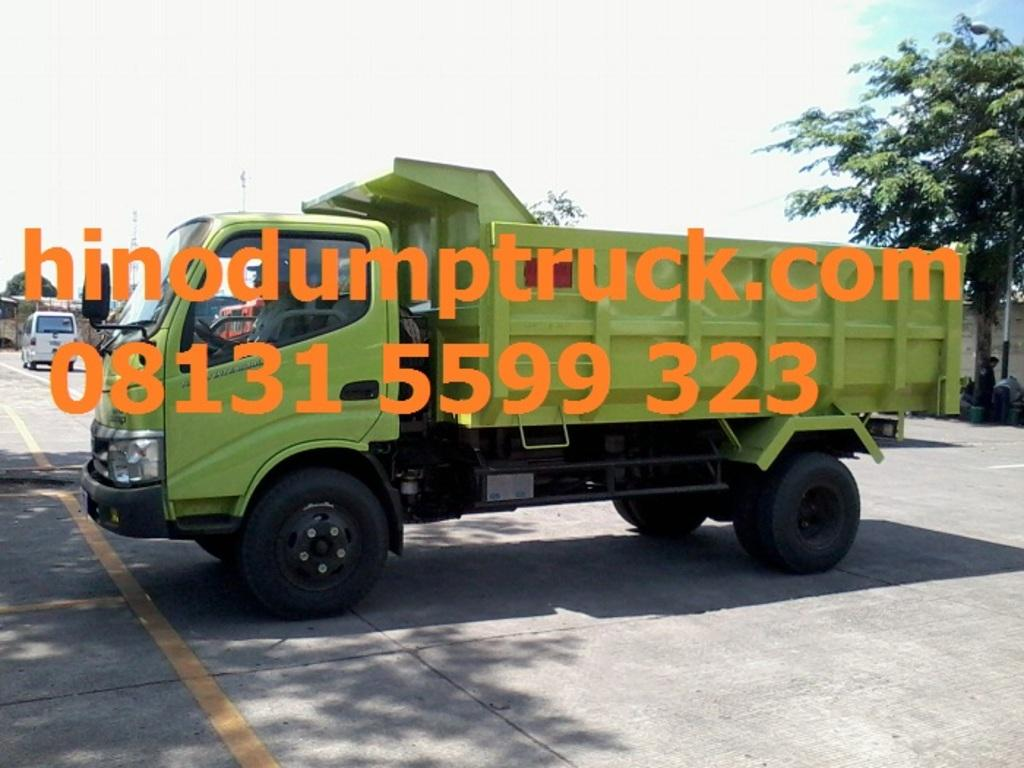What can be seen on the road in the image? There are vehicles on the road in the image. What is visible in the background of the image? There are trees in the background of the image. What part of the natural environment is visible in the image? The sky is visible in the image. What can be seen in the sky? Clouds are present in the sky. What else is visible in the image besides the vehicles, trees, and sky? There is text and numbers visible in the image. What type of shoes is the father wearing in the image? There is no father or shoes present in the image. Can you describe the hook that is hanging from the tree in the image? There is no hook hanging from a tree in the image. 